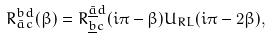<formula> <loc_0><loc_0><loc_500><loc_500>R _ { \bar { a } c } ^ { b d } ( \beta ) = R _ { \underline { b } c } ^ { \underline { \bar { a } } d } ( i \pi - \beta ) U _ { R L } ( i \pi - 2 \beta ) ,</formula> 